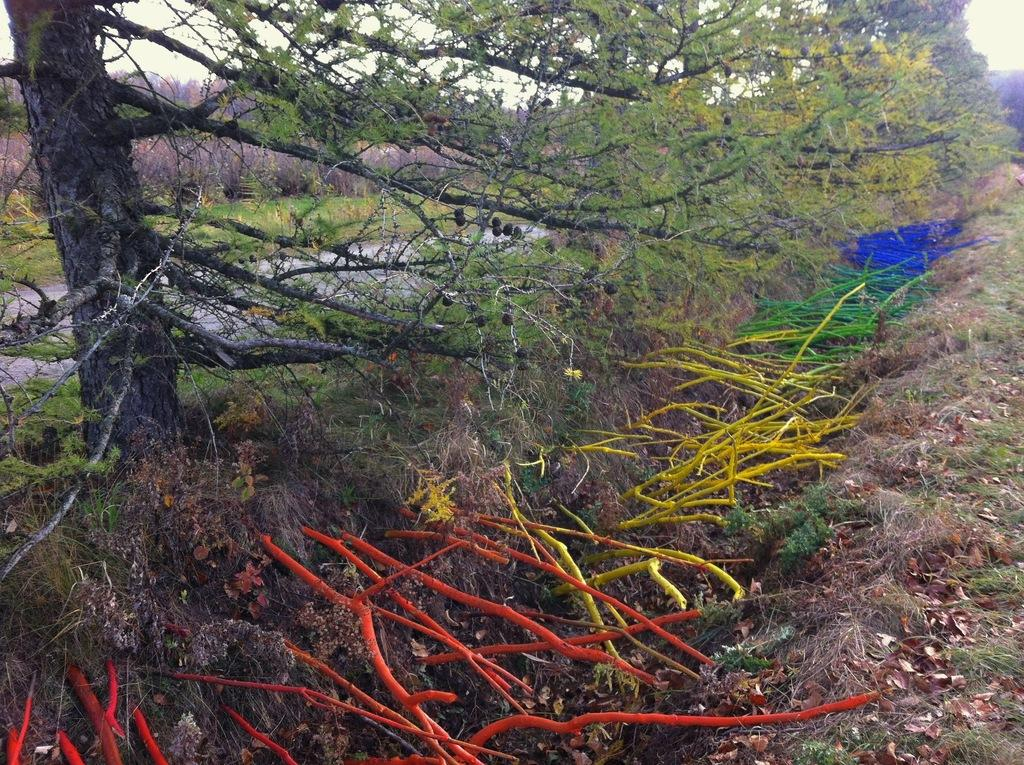What type of vegetation can be seen at the bottom of the image? There is grass and leaves at the bottom of the image. What other objects are present at the bottom of the image? There are colorful sticks on the ground at the bottom of the image. What can be seen in the background of the image? There are trees, water, and the sky visible in the background of the image. How much wealth is represented by the grape in the image? There is no grape present in the image, so it is not possible to determine the amount of wealth represented. What type of beast can be seen interacting with the water in the image? There are no beasts present in the image; only trees, water, and the sky are visible in the background. 